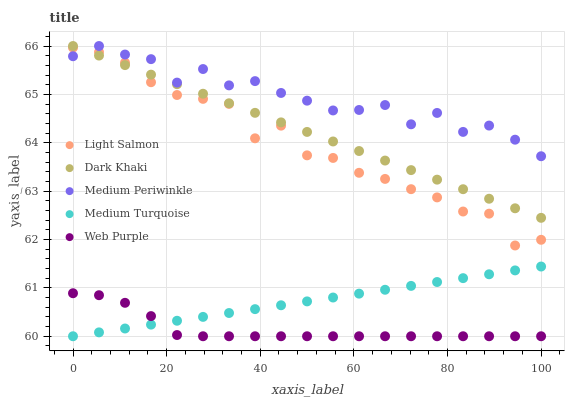Does Web Purple have the minimum area under the curve?
Answer yes or no. Yes. Does Medium Periwinkle have the maximum area under the curve?
Answer yes or no. Yes. Does Light Salmon have the minimum area under the curve?
Answer yes or no. No. Does Light Salmon have the maximum area under the curve?
Answer yes or no. No. Is Medium Turquoise the smoothest?
Answer yes or no. Yes. Is Medium Periwinkle the roughest?
Answer yes or no. Yes. Is Light Salmon the smoothest?
Answer yes or no. No. Is Light Salmon the roughest?
Answer yes or no. No. Does Web Purple have the lowest value?
Answer yes or no. Yes. Does Light Salmon have the lowest value?
Answer yes or no. No. Does Medium Periwinkle have the highest value?
Answer yes or no. Yes. Does Light Salmon have the highest value?
Answer yes or no. No. Is Web Purple less than Light Salmon?
Answer yes or no. Yes. Is Medium Periwinkle greater than Web Purple?
Answer yes or no. Yes. Does Light Salmon intersect Dark Khaki?
Answer yes or no. Yes. Is Light Salmon less than Dark Khaki?
Answer yes or no. No. Is Light Salmon greater than Dark Khaki?
Answer yes or no. No. Does Web Purple intersect Light Salmon?
Answer yes or no. No. 